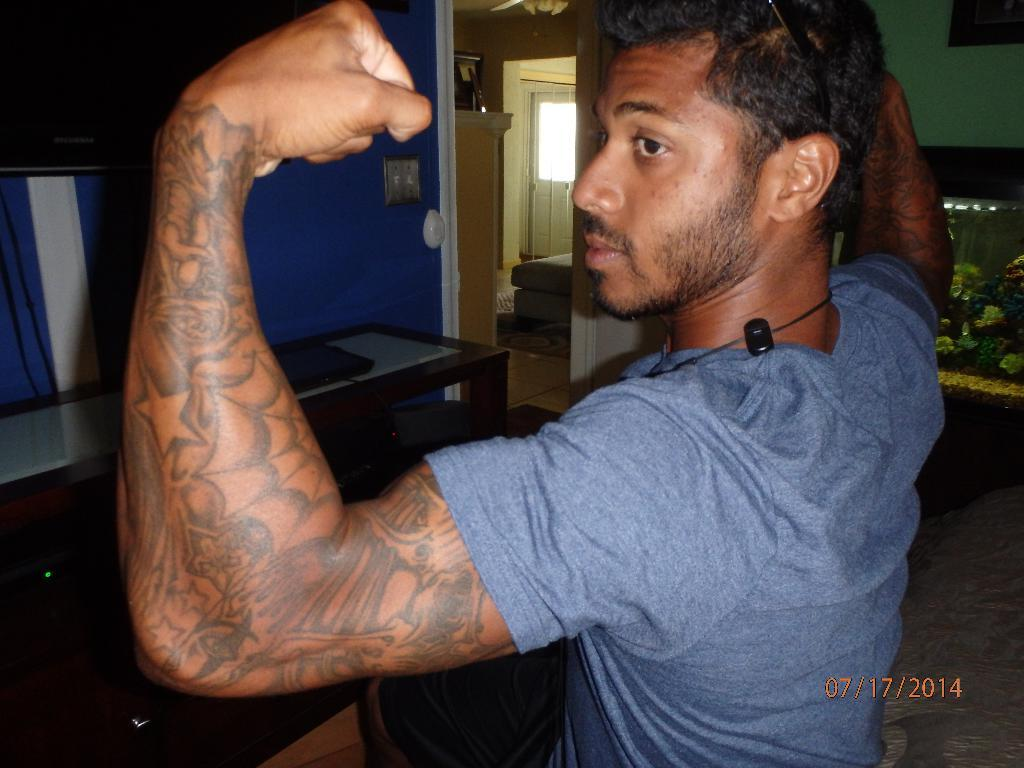What is the main subject of the image? There is a man standing in the image. Can you describe any distinguishing features of the man? The man has tattoos on his hands. What object is present in the image besides the man? There is a table in the image. What can be seen in the background of the image? There is a house in the background of the image. How many babies are crawling on the table in the image? There are no babies present in the image; it only features a man with tattoos on his hands, a table, and a house in the background. 